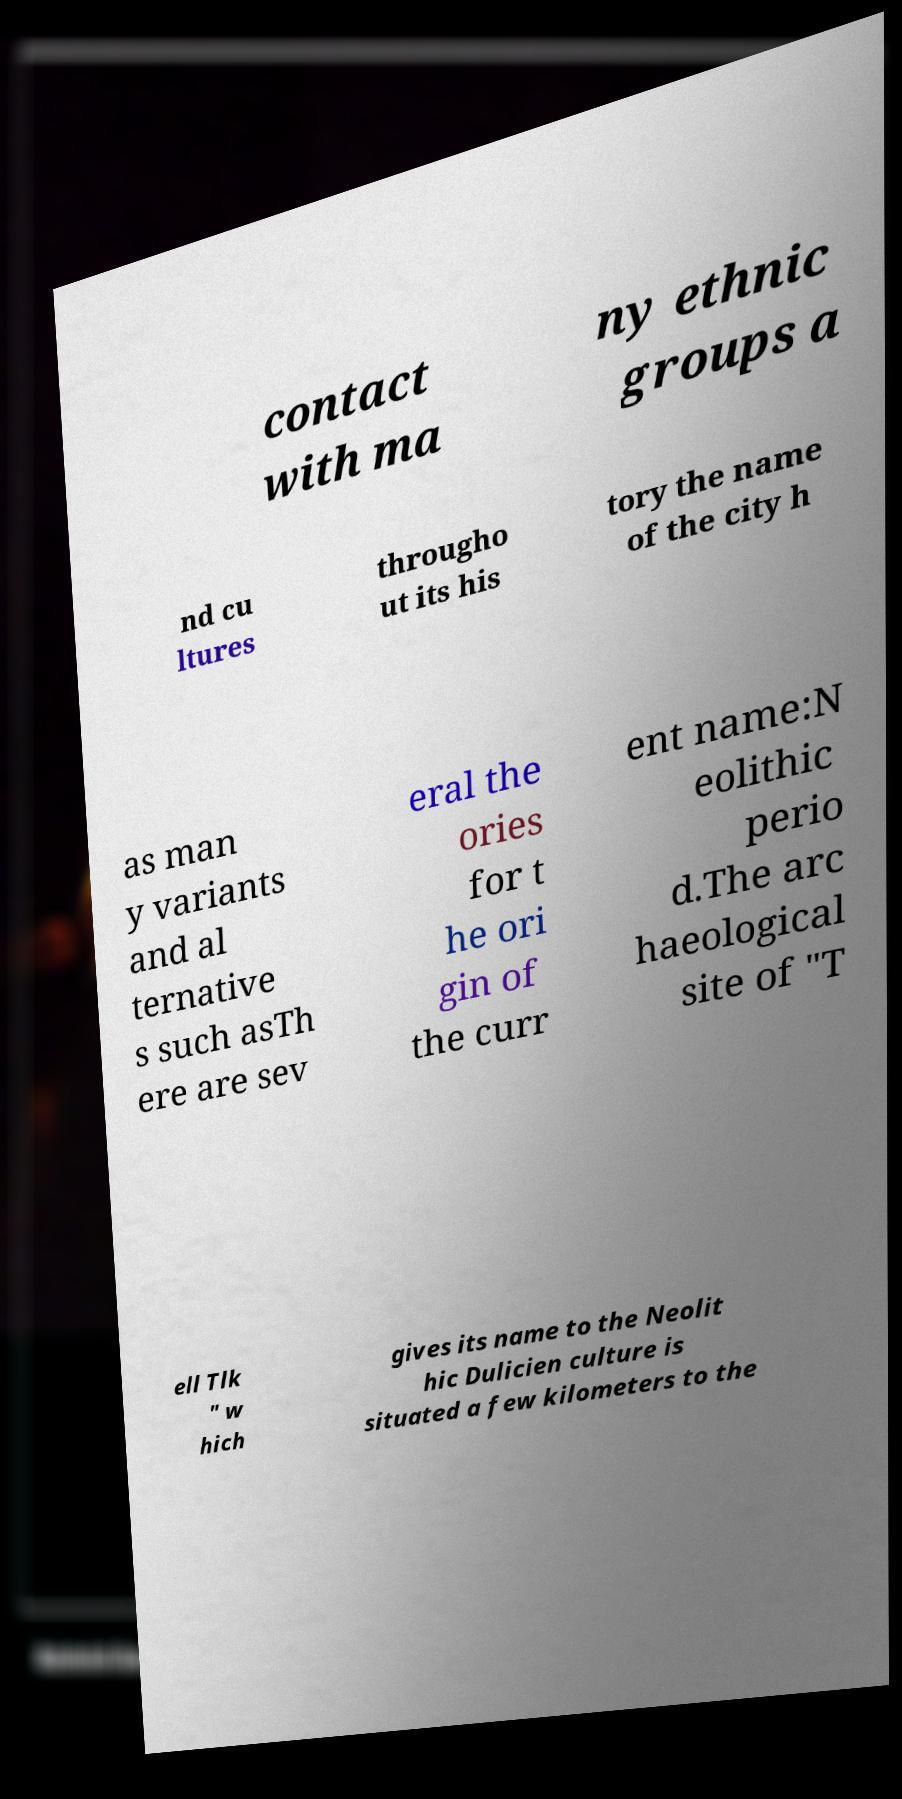Could you extract and type out the text from this image? contact with ma ny ethnic groups a nd cu ltures througho ut its his tory the name of the city h as man y variants and al ternative s such asTh ere are sev eral the ories for t he ori gin of the curr ent name:N eolithic perio d.The arc haeological site of "T ell Tlk " w hich gives its name to the Neolit hic Dulicien culture is situated a few kilometers to the 